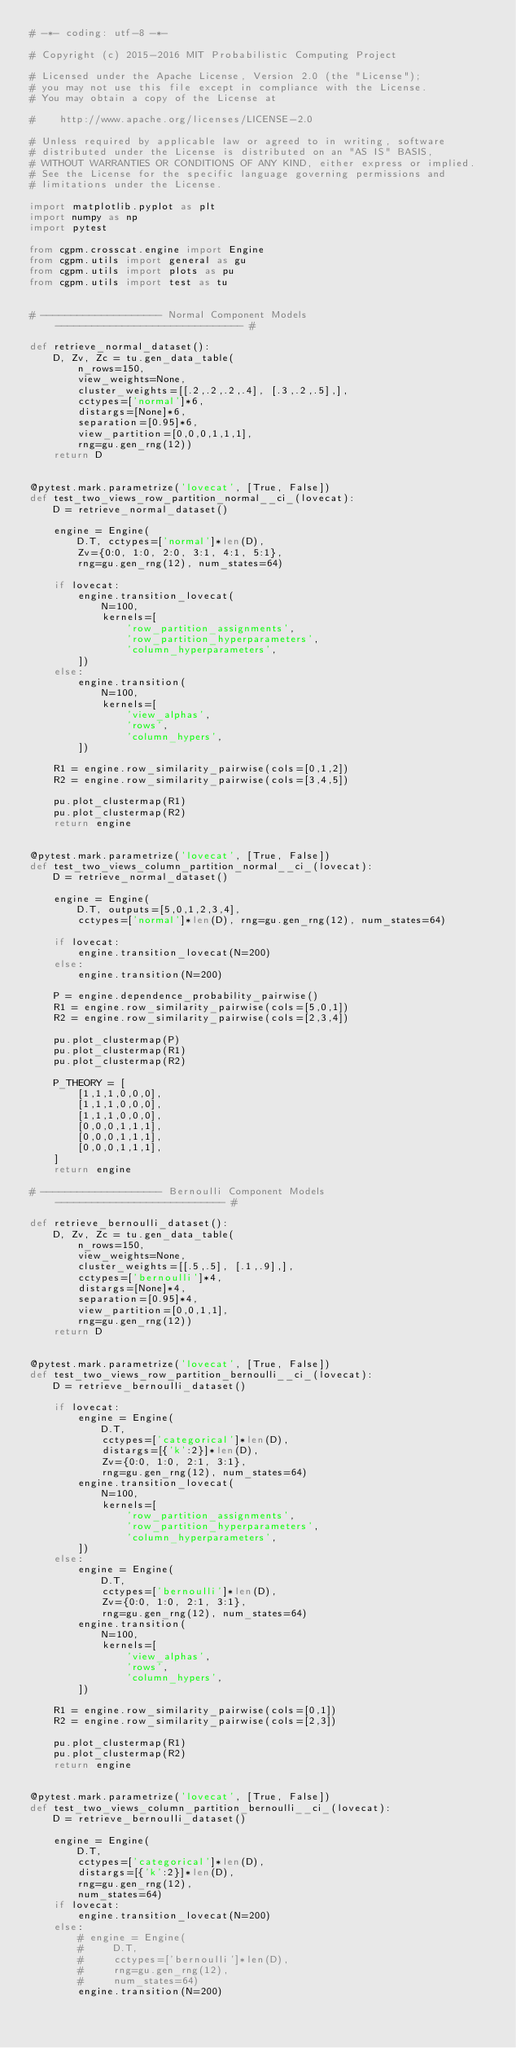Convert code to text. <code><loc_0><loc_0><loc_500><loc_500><_Python_># -*- coding: utf-8 -*-

# Copyright (c) 2015-2016 MIT Probabilistic Computing Project

# Licensed under the Apache License, Version 2.0 (the "License");
# you may not use this file except in compliance with the License.
# You may obtain a copy of the License at

#    http://www.apache.org/licenses/LICENSE-2.0

# Unless required by applicable law or agreed to in writing, software
# distributed under the License is distributed on an "AS IS" BASIS,
# WITHOUT WARRANTIES OR CONDITIONS OF ANY KIND, either express or implied.
# See the License for the specific language governing permissions and
# limitations under the License.

import matplotlib.pyplot as plt
import numpy as np
import pytest

from cgpm.crosscat.engine import Engine
from cgpm.utils import general as gu
from cgpm.utils import plots as pu
from cgpm.utils import test as tu


# -------------------- Normal Component Models ------------------------------- #

def retrieve_normal_dataset():
    D, Zv, Zc = tu.gen_data_table(
        n_rows=150,
        view_weights=None,
        cluster_weights=[[.2,.2,.2,.4], [.3,.2,.5],],
        cctypes=['normal']*6,
        distargs=[None]*6,
        separation=[0.95]*6,
        view_partition=[0,0,0,1,1,1],
        rng=gu.gen_rng(12))
    return D


@pytest.mark.parametrize('lovecat', [True, False])
def test_two_views_row_partition_normal__ci_(lovecat):
    D = retrieve_normal_dataset()

    engine = Engine(
        D.T, cctypes=['normal']*len(D),
        Zv={0:0, 1:0, 2:0, 3:1, 4:1, 5:1},
        rng=gu.gen_rng(12), num_states=64)

    if lovecat:
        engine.transition_lovecat(
            N=100,
            kernels=[
                'row_partition_assignments',
                'row_partition_hyperparameters',
                'column_hyperparameters',
        ])
    else:
        engine.transition(
            N=100,
            kernels=[
                'view_alphas',
                'rows',
                'column_hypers',
        ])

    R1 = engine.row_similarity_pairwise(cols=[0,1,2])
    R2 = engine.row_similarity_pairwise(cols=[3,4,5])

    pu.plot_clustermap(R1)
    pu.plot_clustermap(R2)
    return engine


@pytest.mark.parametrize('lovecat', [True, False])
def test_two_views_column_partition_normal__ci_(lovecat):
    D = retrieve_normal_dataset()

    engine = Engine(
        D.T, outputs=[5,0,1,2,3,4],
        cctypes=['normal']*len(D), rng=gu.gen_rng(12), num_states=64)

    if lovecat:
        engine.transition_lovecat(N=200)
    else:
        engine.transition(N=200)

    P = engine.dependence_probability_pairwise()
    R1 = engine.row_similarity_pairwise(cols=[5,0,1])
    R2 = engine.row_similarity_pairwise(cols=[2,3,4])

    pu.plot_clustermap(P)
    pu.plot_clustermap(R1)
    pu.plot_clustermap(R2)

    P_THEORY = [
        [1,1,1,0,0,0],
        [1,1,1,0,0,0],
        [1,1,1,0,0,0],
        [0,0,0,1,1,1],
        [0,0,0,1,1,1],
        [0,0,0,1,1,1],
    ]
    return engine

# -------------------- Bernoulli Component Models ---------------------------- #

def retrieve_bernoulli_dataset():
    D, Zv, Zc = tu.gen_data_table(
        n_rows=150,
        view_weights=None,
        cluster_weights=[[.5,.5], [.1,.9],],
        cctypes=['bernoulli']*4,
        distargs=[None]*4,
        separation=[0.95]*4,
        view_partition=[0,0,1,1],
        rng=gu.gen_rng(12))
    return D


@pytest.mark.parametrize('lovecat', [True, False])
def test_two_views_row_partition_bernoulli__ci_(lovecat):
    D = retrieve_bernoulli_dataset()

    if lovecat:
        engine = Engine(
            D.T,
            cctypes=['categorical']*len(D),
            distargs=[{'k':2}]*len(D),
            Zv={0:0, 1:0, 2:1, 3:1},
            rng=gu.gen_rng(12), num_states=64)
        engine.transition_lovecat(
            N=100,
            kernels=[
                'row_partition_assignments',
                'row_partition_hyperparameters',
                'column_hyperparameters',
        ])
    else:
        engine = Engine(
            D.T,
            cctypes=['bernoulli']*len(D),
            Zv={0:0, 1:0, 2:1, 3:1},
            rng=gu.gen_rng(12), num_states=64)
        engine.transition(
            N=100,
            kernels=[
                'view_alphas',
                'rows',
                'column_hypers',
        ])

    R1 = engine.row_similarity_pairwise(cols=[0,1])
    R2 = engine.row_similarity_pairwise(cols=[2,3])

    pu.plot_clustermap(R1)
    pu.plot_clustermap(R2)
    return engine


@pytest.mark.parametrize('lovecat', [True, False])
def test_two_views_column_partition_bernoulli__ci_(lovecat):
    D = retrieve_bernoulli_dataset()

    engine = Engine(
        D.T,
        cctypes=['categorical']*len(D),
        distargs=[{'k':2}]*len(D),
        rng=gu.gen_rng(12),
        num_states=64)
    if lovecat:
        engine.transition_lovecat(N=200)
    else:
        # engine = Engine(
        #     D.T,
        #     cctypes=['bernoulli']*len(D),
        #     rng=gu.gen_rng(12),
        #     num_states=64)
        engine.transition(N=200)
</code> 